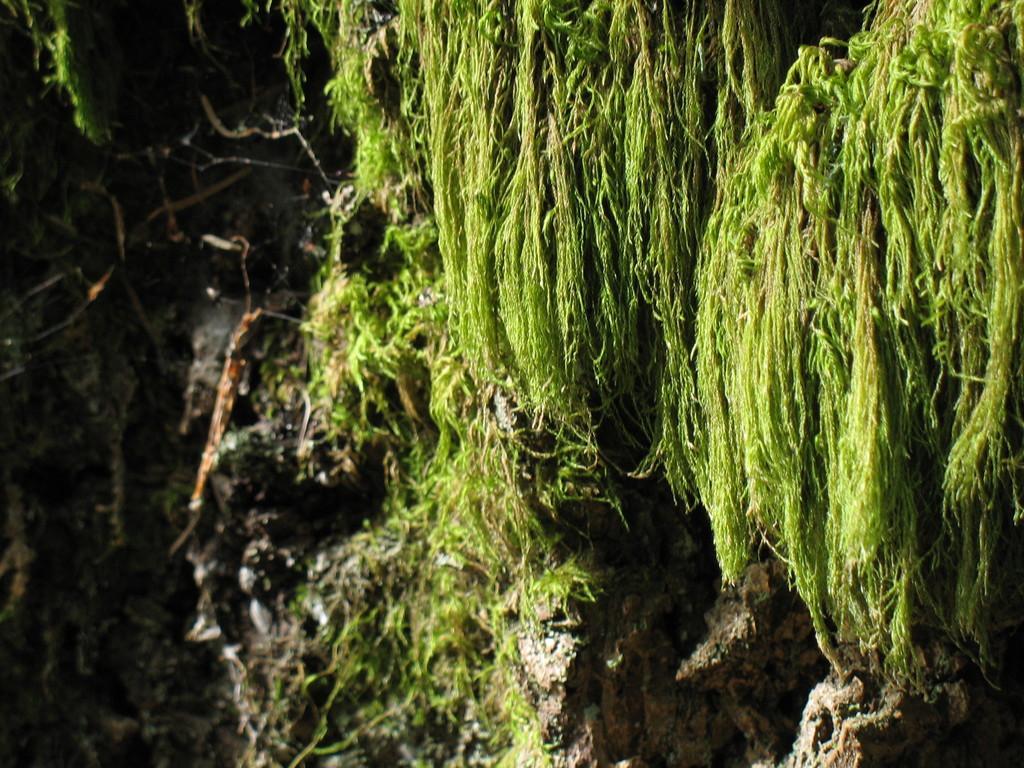Please provide a concise description of this image. In this picture we can see some plants. 